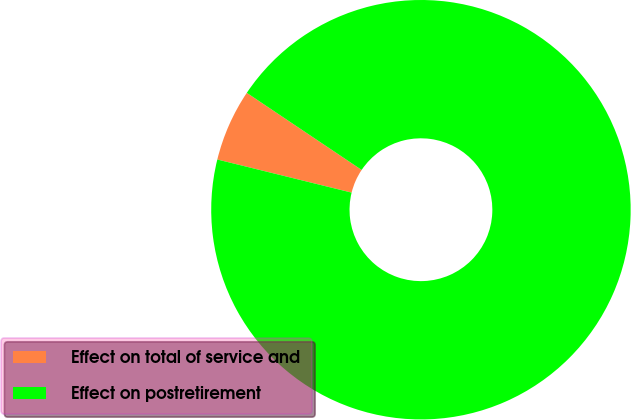<chart> <loc_0><loc_0><loc_500><loc_500><pie_chart><fcel>Effect on total of service and<fcel>Effect on postretirement<nl><fcel>5.56%<fcel>94.44%<nl></chart> 